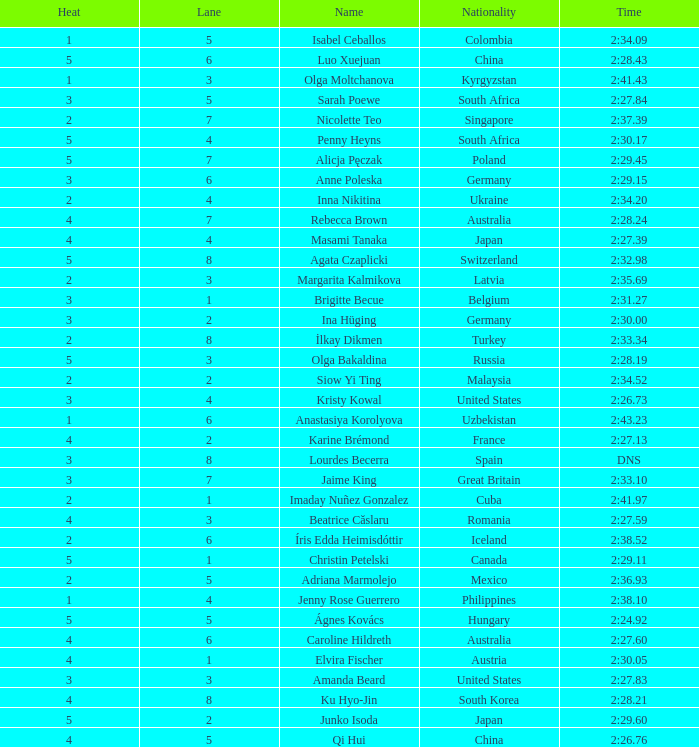What is the name that saw 4 heats and a lane higher than 7? Ku Hyo-Jin. 